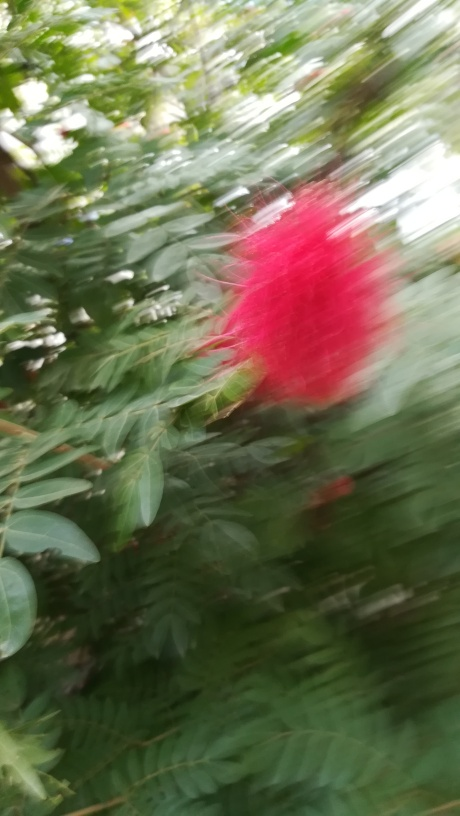What can be said about the overall quality of this image? The quality of the image is suboptimal due to motion blur and lack of focus, which obscures the details of the subject. It appears to be a hastily taken photograph of a plant with red blooms, in a natural setting. The composition and lighting could potentially be good, but these aspects are overshadowed by the blurriness of the image. 